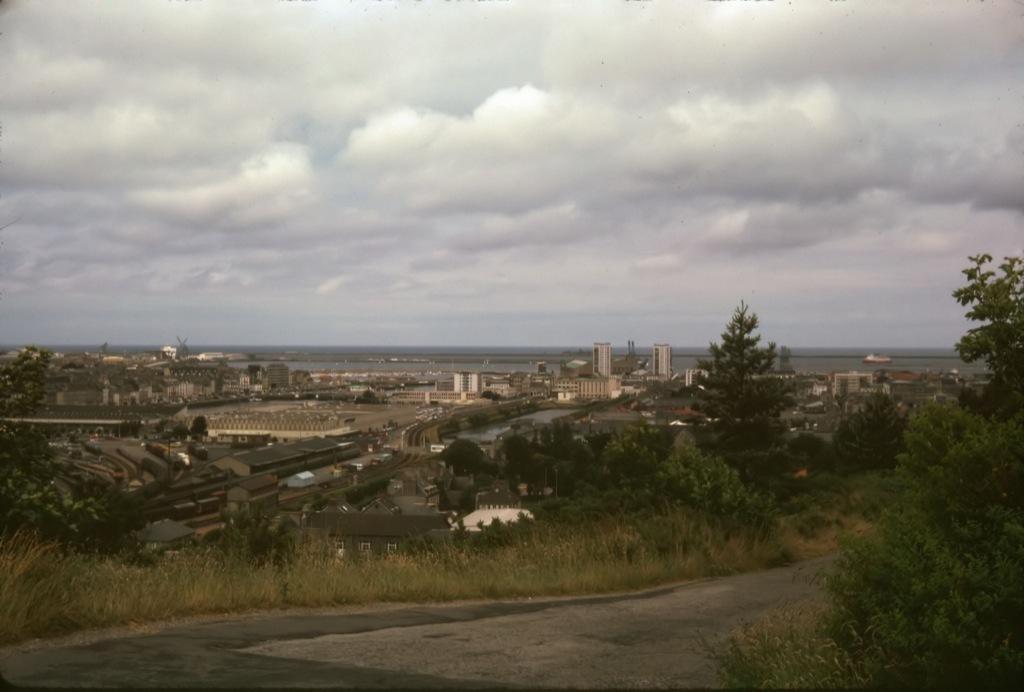In one or two sentences, can you explain what this image depicts? In this image I can see the road. I can see few buildings. There are few trees. At the top I can see clouds in the sky. 